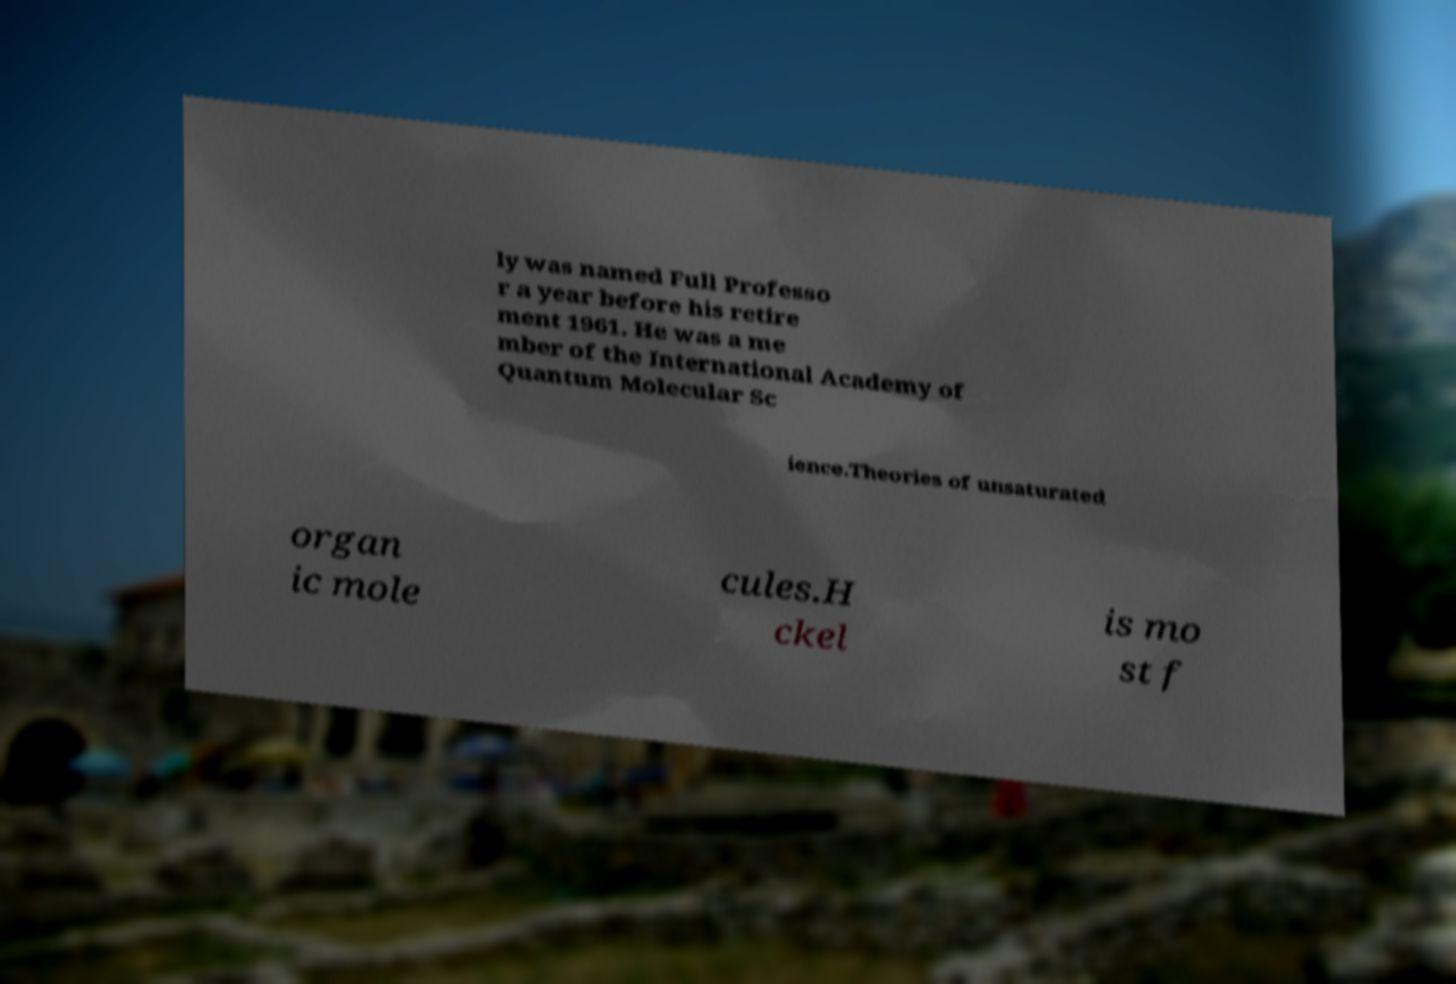Could you assist in decoding the text presented in this image and type it out clearly? ly was named Full Professo r a year before his retire ment 1961. He was a me mber of the International Academy of Quantum Molecular Sc ience.Theories of unsaturated organ ic mole cules.H ckel is mo st f 